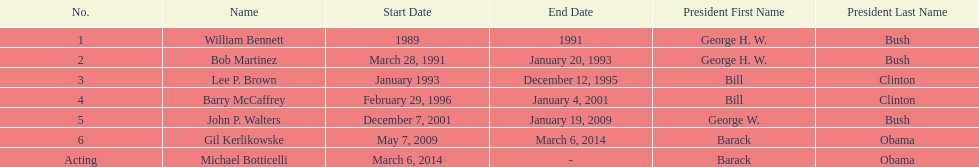How long did the first director serve in office? 2 years. 